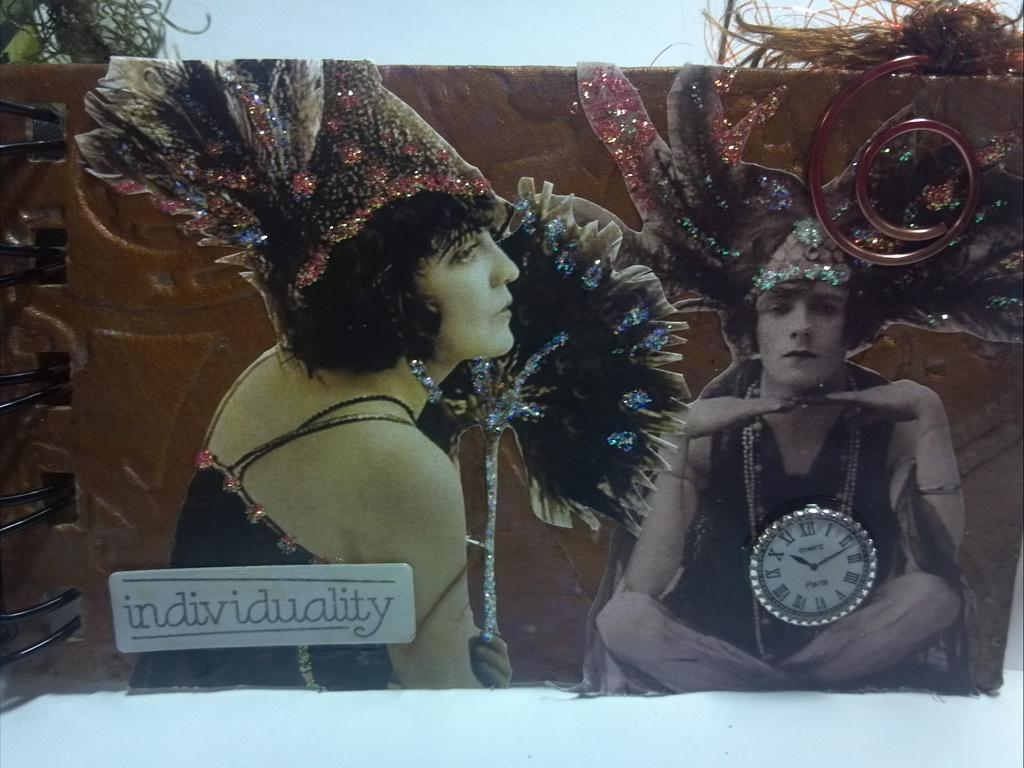<image>
Render a clear and concise summary of the photo. Artwork is displayed on people wearing costumes showing their individuality 